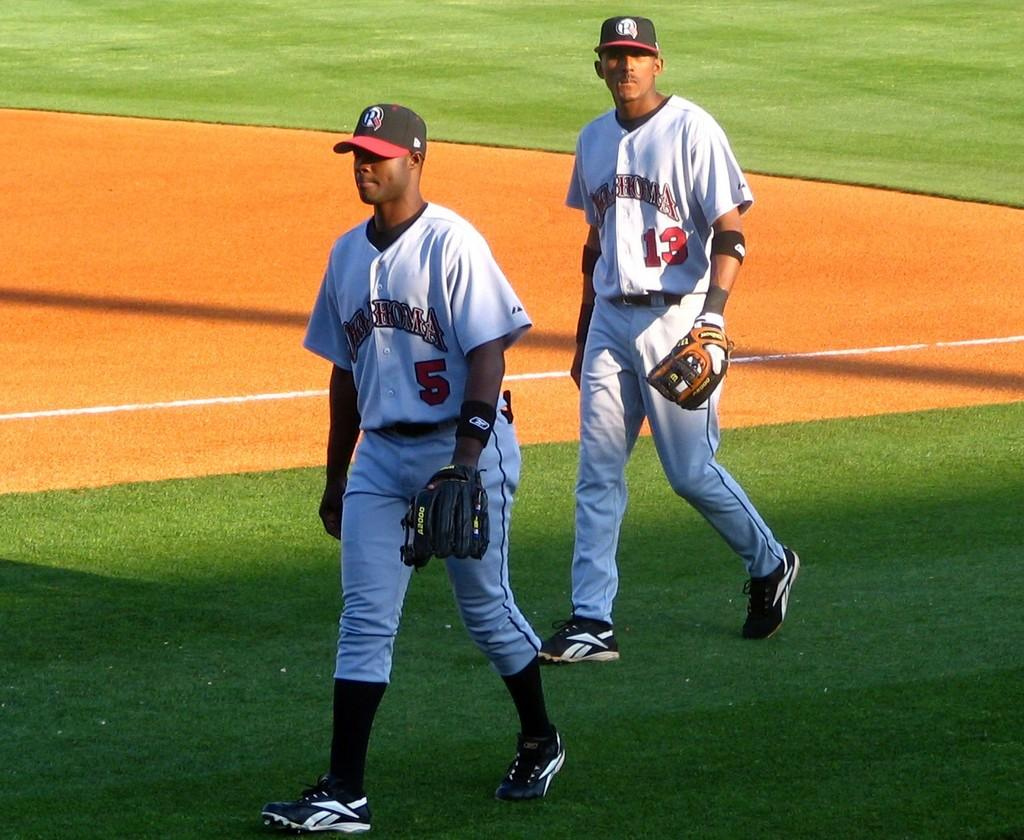<image>
Relay a brief, clear account of the picture shown. baseball players 5 and 13 with mitts walking off field 